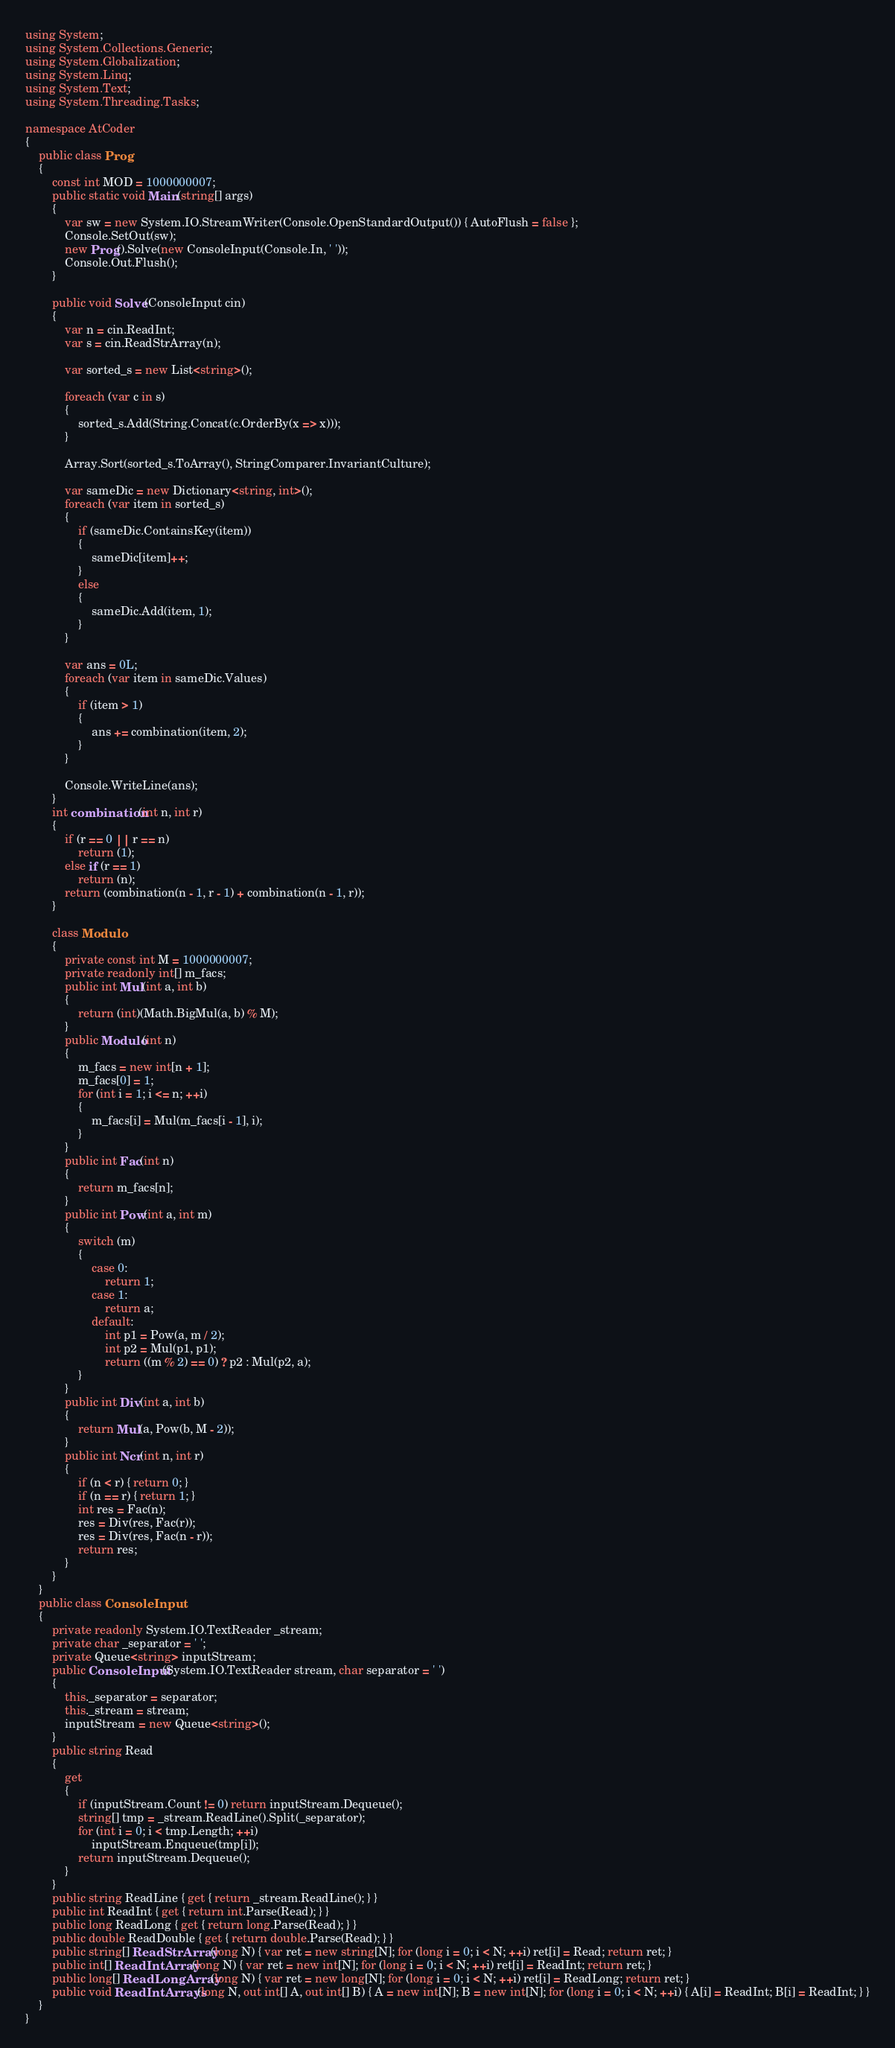Convert code to text. <code><loc_0><loc_0><loc_500><loc_500><_C#_>using System;
using System.Collections.Generic;
using System.Globalization;
using System.Linq;
using System.Text;
using System.Threading.Tasks;

namespace AtCoder
{
    public class Prog
    {
        const int MOD = 1000000007;
        public static void Main(string[] args)
        {
            var sw = new System.IO.StreamWriter(Console.OpenStandardOutput()) { AutoFlush = false };
            Console.SetOut(sw);
            new Prog().Solve(new ConsoleInput(Console.In, ' '));
            Console.Out.Flush();
        }

        public void Solve(ConsoleInput cin)
        {
            var n = cin.ReadInt;
            var s = cin.ReadStrArray(n);

            var sorted_s = new List<string>();

            foreach (var c in s)
            {
                sorted_s.Add(String.Concat(c.OrderBy(x => x)));
            }

            Array.Sort(sorted_s.ToArray(), StringComparer.InvariantCulture);

            var sameDic = new Dictionary<string, int>();
            foreach (var item in sorted_s)
            {
                if (sameDic.ContainsKey(item))
                {
                    sameDic[item]++;
                }
                else
                {
                    sameDic.Add(item, 1);
                }
            }

            var ans = 0L;
            foreach (var item in sameDic.Values)
            {
                if (item > 1)
                {
                    ans += combination(item, 2);
                }
            }

            Console.WriteLine(ans);
        }
        int combination(int n, int r)
        {
            if (r == 0 || r == n)
                return (1);
            else if (r == 1)
                return (n);
            return (combination(n - 1, r - 1) + combination(n - 1, r));
        }

        class Modulo
        {
            private const int M = 1000000007;
            private readonly int[] m_facs;
            public int Mul(int a, int b)
            {
                return (int)(Math.BigMul(a, b) % M);
            }
            public Modulo(int n)
            {
                m_facs = new int[n + 1];
                m_facs[0] = 1;
                for (int i = 1; i <= n; ++i)
                {
                    m_facs[i] = Mul(m_facs[i - 1], i);
                }
            }
            public int Fac(int n)
            {
                return m_facs[n];
            }
            public int Pow(int a, int m)
            {
                switch (m)
                {
                    case 0:
                        return 1;
                    case 1:
                        return a;
                    default:
                        int p1 = Pow(a, m / 2);
                        int p2 = Mul(p1, p1);
                        return ((m % 2) == 0) ? p2 : Mul(p2, a);
                }
            }
            public int Div(int a, int b)
            {
                return Mul(a, Pow(b, M - 2));
            }
            public int Ncr(int n, int r)
            {
                if (n < r) { return 0; }
                if (n == r) { return 1; }
                int res = Fac(n);
                res = Div(res, Fac(r));
                res = Div(res, Fac(n - r));
                return res;
            }
        }
    }
    public class ConsoleInput
    {
        private readonly System.IO.TextReader _stream;
        private char _separator = ' ';
        private Queue<string> inputStream;
        public ConsoleInput(System.IO.TextReader stream, char separator = ' ')
        {
            this._separator = separator;
            this._stream = stream;
            inputStream = new Queue<string>();
        }
        public string Read
        {
            get
            {
                if (inputStream.Count != 0) return inputStream.Dequeue();
                string[] tmp = _stream.ReadLine().Split(_separator);
                for (int i = 0; i < tmp.Length; ++i)
                    inputStream.Enqueue(tmp[i]);
                return inputStream.Dequeue();
            }
        }
        public string ReadLine { get { return _stream.ReadLine(); } }
        public int ReadInt { get { return int.Parse(Read); } }
        public long ReadLong { get { return long.Parse(Read); } }
        public double ReadDouble { get { return double.Parse(Read); } }
        public string[] ReadStrArray(long N) { var ret = new string[N]; for (long i = 0; i < N; ++i) ret[i] = Read; return ret; }
        public int[] ReadIntArray(long N) { var ret = new int[N]; for (long i = 0; i < N; ++i) ret[i] = ReadInt; return ret; }
        public long[] ReadLongArray(long N) { var ret = new long[N]; for (long i = 0; i < N; ++i) ret[i] = ReadLong; return ret; }
        public void ReadIntArrays(long N, out int[] A, out int[] B) { A = new int[N]; B = new int[N]; for (long i = 0; i < N; ++i) { A[i] = ReadInt; B[i] = ReadInt; } }
    }
}
</code> 